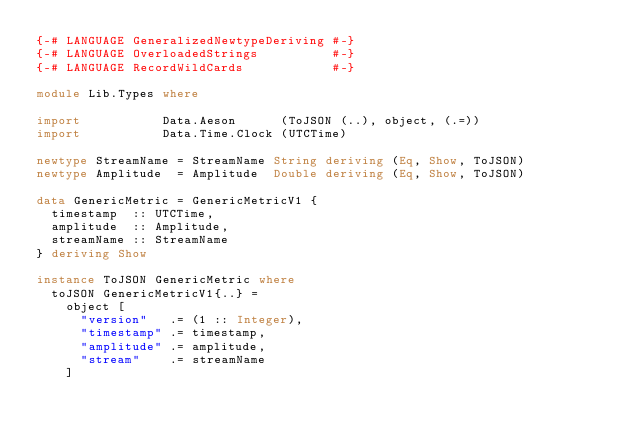<code> <loc_0><loc_0><loc_500><loc_500><_Haskell_>{-# LANGUAGE GeneralizedNewtypeDeriving #-}
{-# LANGUAGE OverloadedStrings          #-}
{-# LANGUAGE RecordWildCards            #-}

module Lib.Types where

import           Data.Aeson      (ToJSON (..), object, (.=))
import           Data.Time.Clock (UTCTime)

newtype StreamName = StreamName String deriving (Eq, Show, ToJSON)
newtype Amplitude  = Amplitude  Double deriving (Eq, Show, ToJSON)

data GenericMetric = GenericMetricV1 {
  timestamp  :: UTCTime,
  amplitude  :: Amplitude,
  streamName :: StreamName
} deriving Show

instance ToJSON GenericMetric where
  toJSON GenericMetricV1{..} =
    object [
      "version"   .= (1 :: Integer),
      "timestamp" .= timestamp,
      "amplitude" .= amplitude,
      "stream"    .= streamName
    ]
</code> 